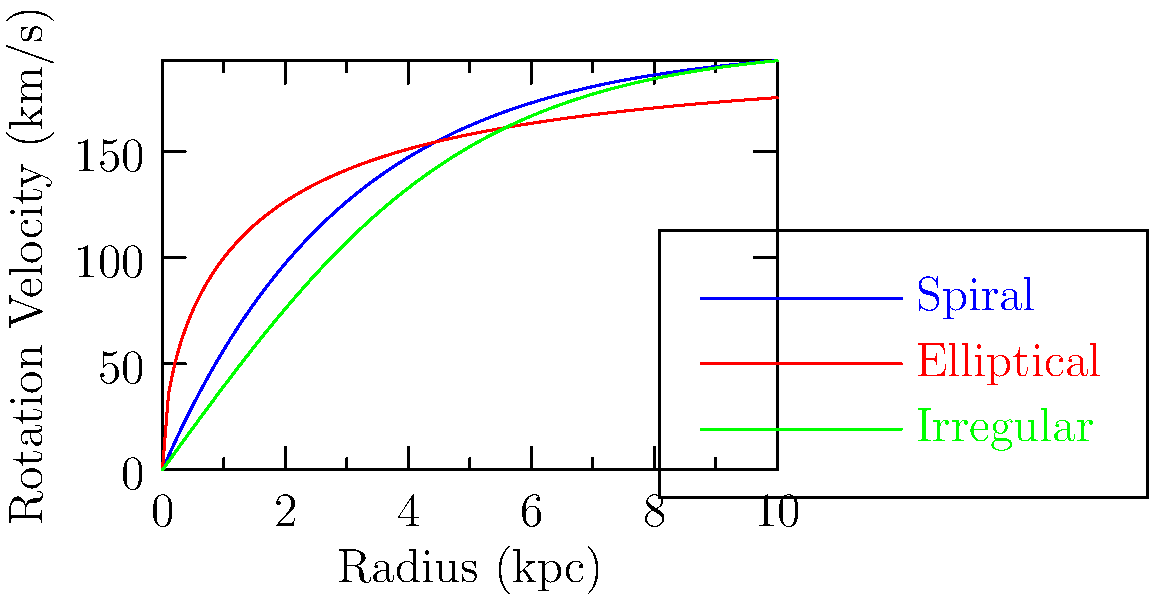Based on the rotation curves shown in the graph, which galaxy type exhibits the most pronounced difference between its inner and outer regions in terms of rotational velocity? To answer this question, we need to analyze the rotation curves for each galaxy type:

1. Spiral galaxy (blue curve):
   - Rises steeply in the inner region
   - Flattens out in the outer region
   - Large difference between inner and outer velocities

2. Elliptical galaxy (red curve):
   - Gradual increase in velocity
   - Continues to rise even in outer regions
   - Moderate difference between inner and outer velocities

3. Irregular galaxy (green curve):
   - Steady increase in velocity
   - Slight flattening in outer regions
   - Smallest difference between inner and outer velocities

The spiral galaxy shows the most dramatic change from a steep rise in the inner region to a flat rotation curve in the outer region. This indicates a significant difference in mass distribution between the inner and outer parts of the galaxy.

The elliptical and irregular galaxies have more gradual changes in their rotation curves, indicating a more uniform mass distribution throughout the galaxy.

Therefore, the spiral galaxy exhibits the most pronounced difference between its inner and outer regions in terms of rotational velocity.
Answer: Spiral galaxy 